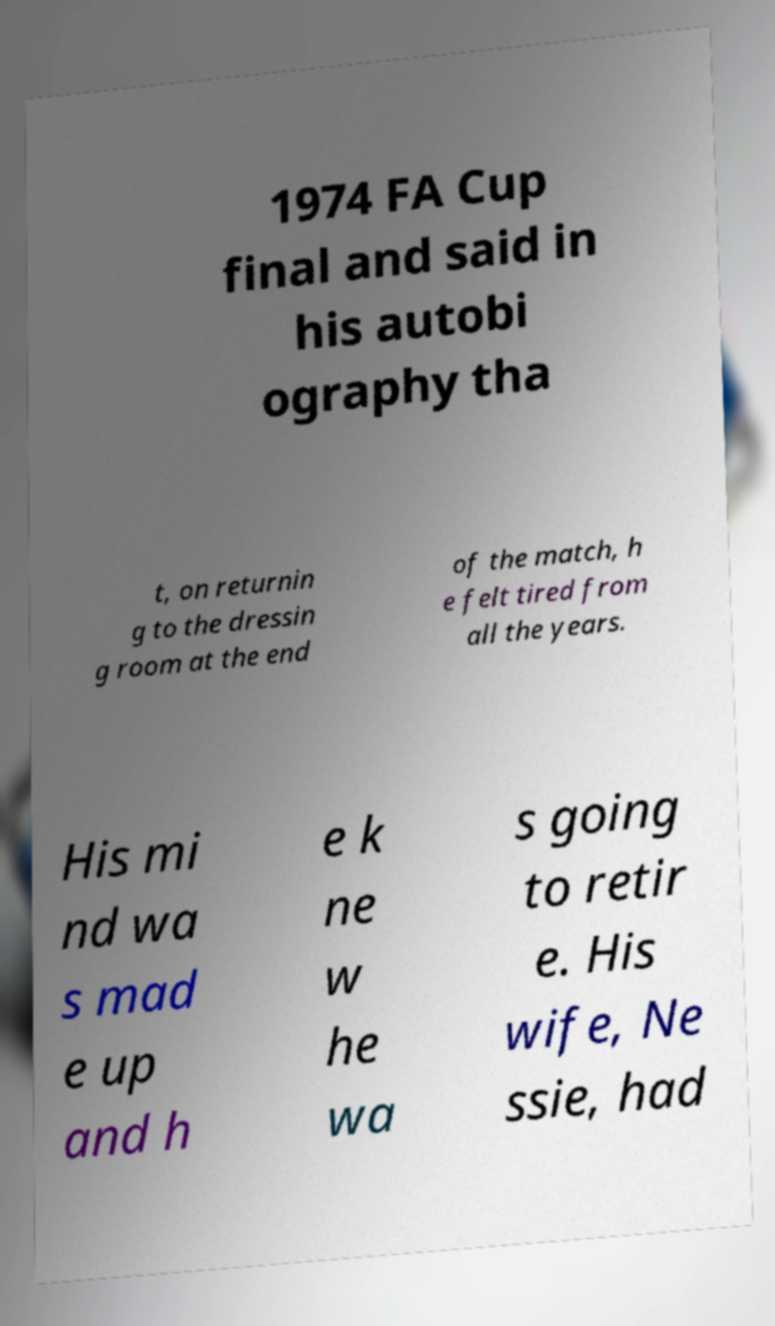Could you extract and type out the text from this image? 1974 FA Cup final and said in his autobi ography tha t, on returnin g to the dressin g room at the end of the match, h e felt tired from all the years. His mi nd wa s mad e up and h e k ne w he wa s going to retir e. His wife, Ne ssie, had 